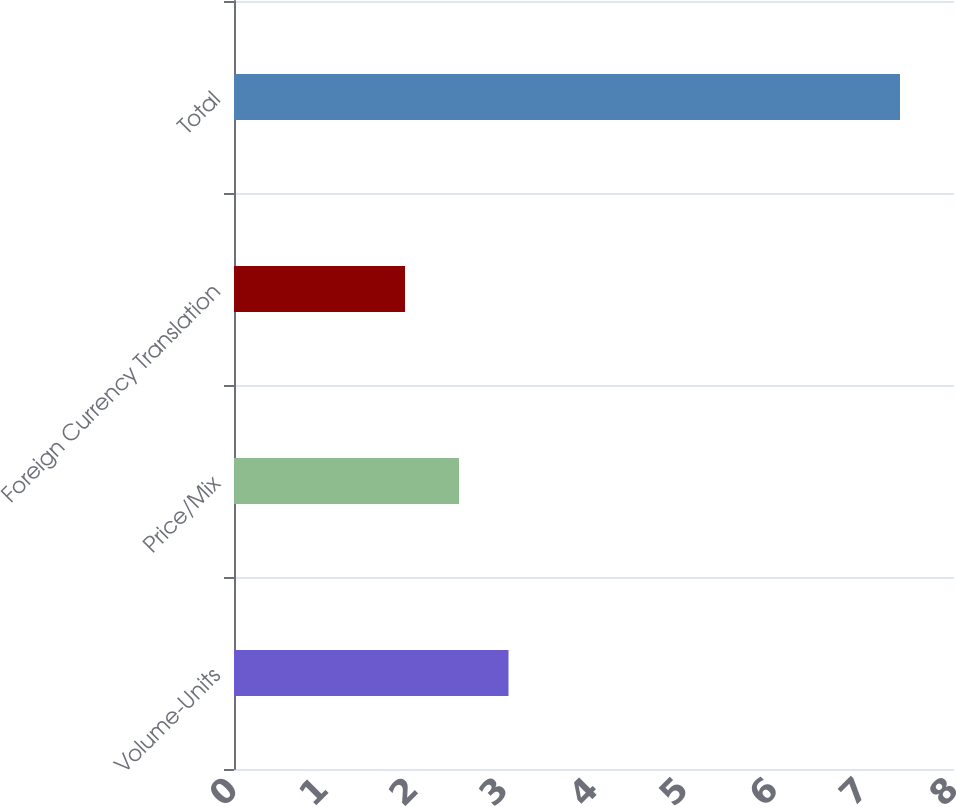Convert chart to OTSL. <chart><loc_0><loc_0><loc_500><loc_500><bar_chart><fcel>Volume-Units<fcel>Price/Mix<fcel>Foreign Currency Translation<fcel>Total<nl><fcel>3.05<fcel>2.5<fcel>1.9<fcel>7.4<nl></chart> 